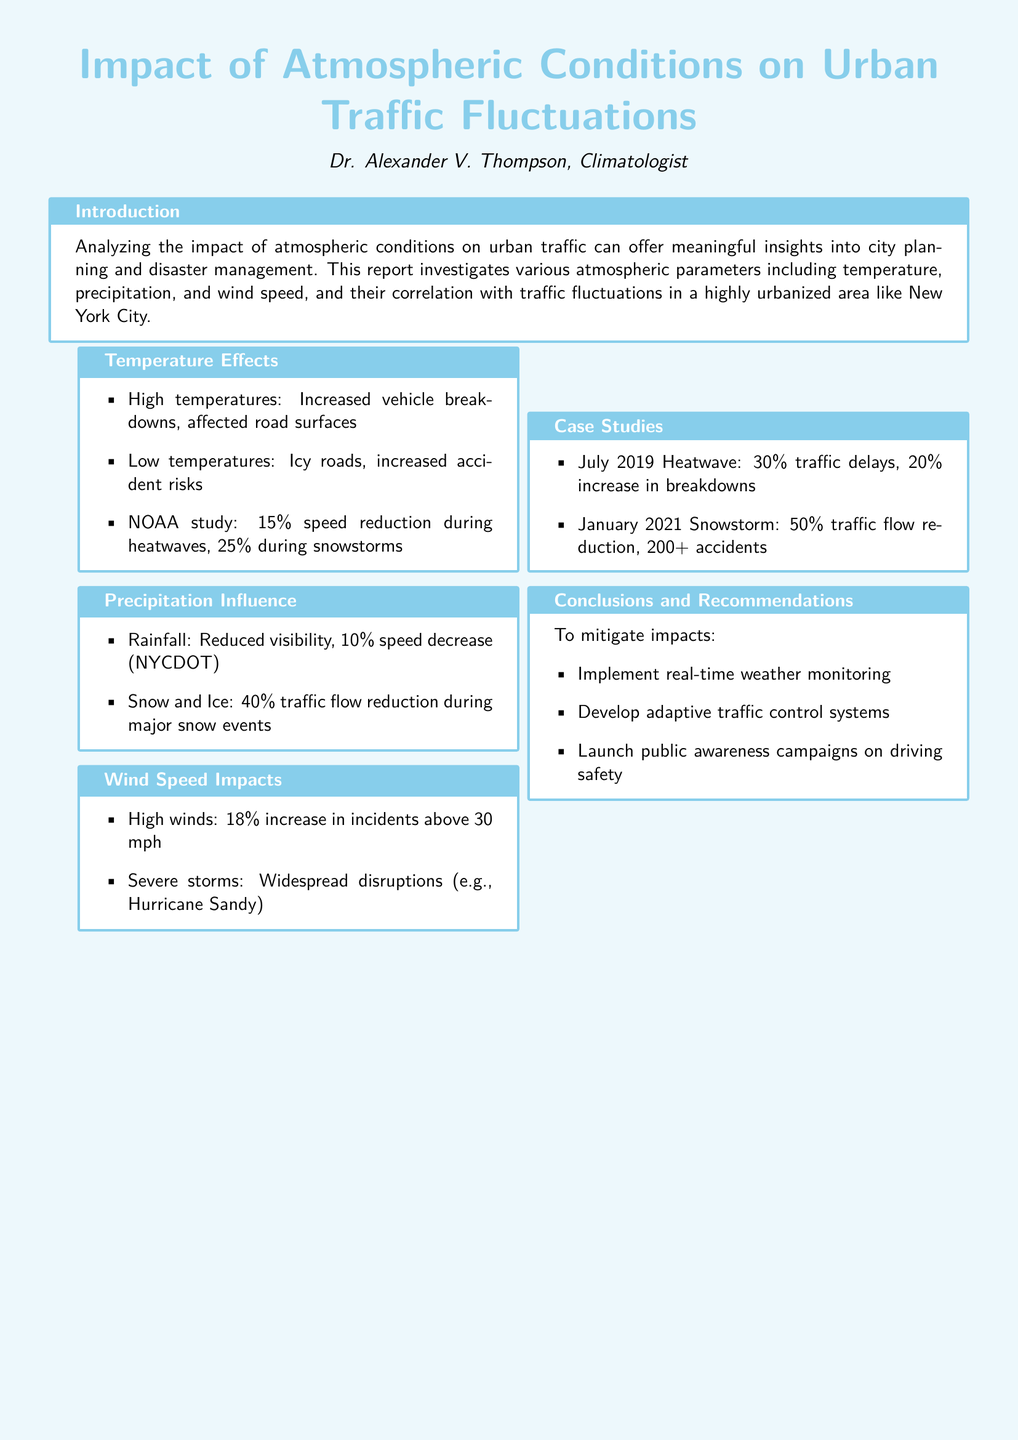What are the atmospheric parameters analyzed? The document discusses atmospheric parameters such as temperature, precipitation, and wind speed and their correlation with traffic fluctuations.
Answer: Temperature, precipitation, wind speed What percentage speed reduction occurs during snowstorms? According to the NOAA study in the document, the speed reduction during snowstorms is 25%.
Answer: 25% What impact does high wind have on incidents? The document states that high winds lead to an 18% increase in incidents above 30 mph.
Answer: 18% What was the traffic flow reduction during the January 2021 snowstorm? The document specifies that traffic flow reduction was 50% during this snowstorm.
Answer: 50% What are two recommendations to mitigate impacts? The document provides several recommendations, two of which are implementing real-time weather monitoring and developing adaptive traffic control systems.
Answer: Real-time weather monitoring, adaptive traffic control systems What was the increase in breakdowns during the July 2019 heatwave? The report notes a 20% increase in breakdowns during the July 2019 heatwave.
Answer: 20% How much is the speed decrease due to rainfall according to NYCDOT? The document indicates a 10% speed decrease due to rainfall.
Answer: 10% What is the primary focus of the report? The primary focus of the report is to analyze the impact of atmospheric conditions on urban traffic fluctuations in a highly urbanized area.
Answer: Urban traffic fluctuations 